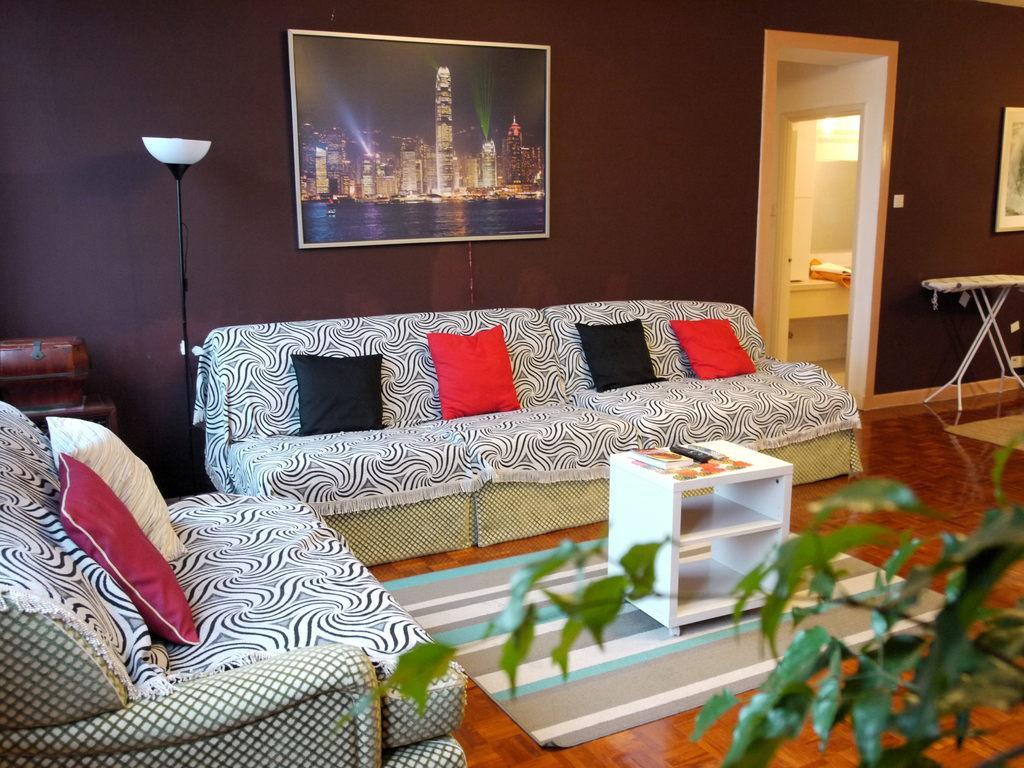Describe this image in one or two sentences. In this image i can see there are two sofa and some cushions on it. Behind the sofa we can see a wall and a wallpaper on it. On the right side of the image we can see a door and in front of the image we can see a plant. In front of the sofa there is a table with some objects on it. On the floor we can see a mat and on the left side of the image we can see a lamp. 